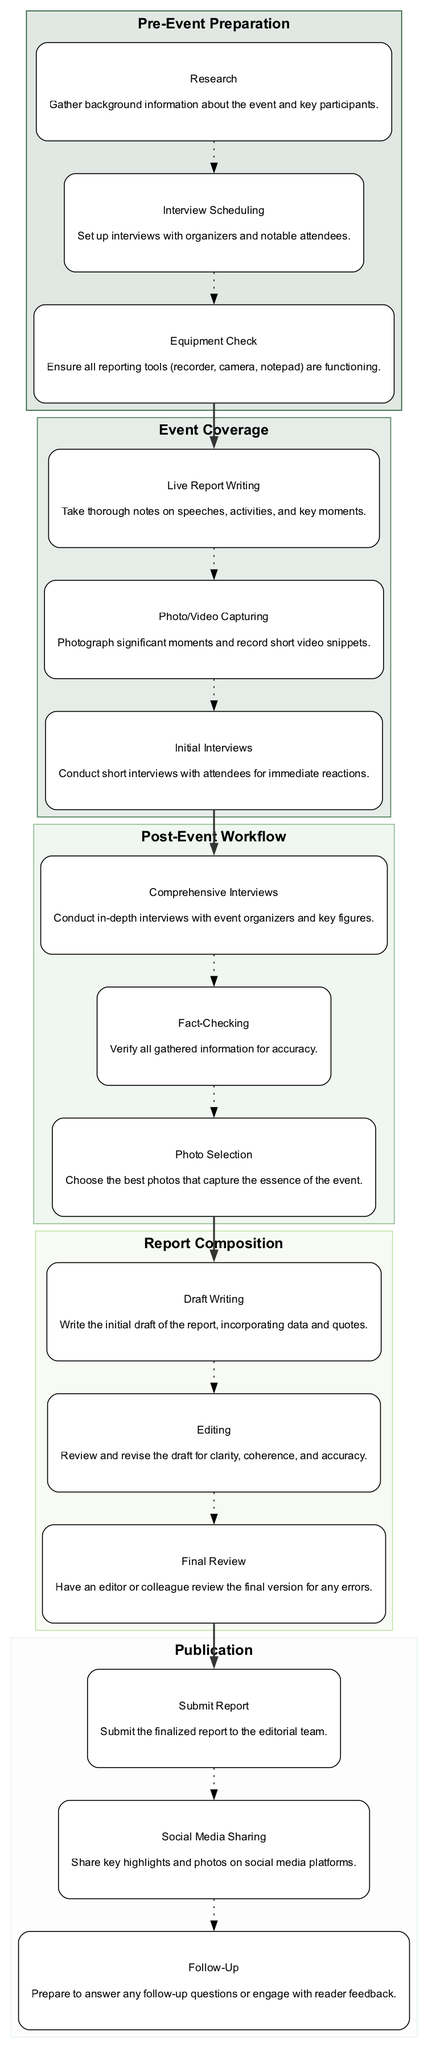What are the essential sections in the structure of a community event report? The diagram outlines five major sections: Pre-Event Preparation, Event Coverage, Post-Event Workflow, Report Composition, and Publication. Each of these sections contains specific tasks related to the reporting process.
Answer: Pre-Event Preparation, Event Coverage, Post-Event Workflow, Report Composition, Publication How many tasks are listed under Post-Event Workflow? The diagram indicates that there are three tasks under the Post-Event Workflow section: Comprehensive Interviews, Fact-Checking, and Photo Selection. These tasks detail what is needed after the event has occurred to finalize the report.
Answer: 3 Which section includes "Draft Writing"? The "Draft Writing" task is located in the Report Composition section, which focuses on the actual writing and editing of the report after the event coverage has occurred.
Answer: Report Composition What is the flow direction between the sections? The flow direction in the diagram moves from Pre-Event Preparation to Event Coverage, then to Post-Event Workflow, followed by Report Composition, and finally to Publication. This indicates the sequence of tasks in producing the community event report.
Answer: Top to Bottom Which task comes immediately after "Photo Selection"? The task that follows "Photo Selection" is "Submit Report," indicating the transition from finalizing the visuals to submitting the completed report to the editorial team for publication.
Answer: Submit Report What happens after the "Initial Interviews"? After the "Initial Interviews," the report writer is expected to engage in the Post-Event Workflow, starting with Comprehensive Interviews to gather more in-depth information for the report.
Answer: Comprehensive Interviews How do the tasks within "Event Coverage" relate to the final report? Tasks in "Event Coverage," such as Live Report Writing and Photo/Video Capturing, provide the primary content for the report. They serve as the foundational information that will be expanded upon during Report Composition.
Answer: They provide foundational content How many edges connect "Live Report Writing" to other nodes? In the diagram, "Live Report Writing" is connected by one edge to "Photo/Video Capturing," representing the relationship in reporting where notes and visual content are developed simultaneously during the event.
Answer: 1 